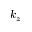<formula> <loc_0><loc_0><loc_500><loc_500>k _ { z }</formula> 